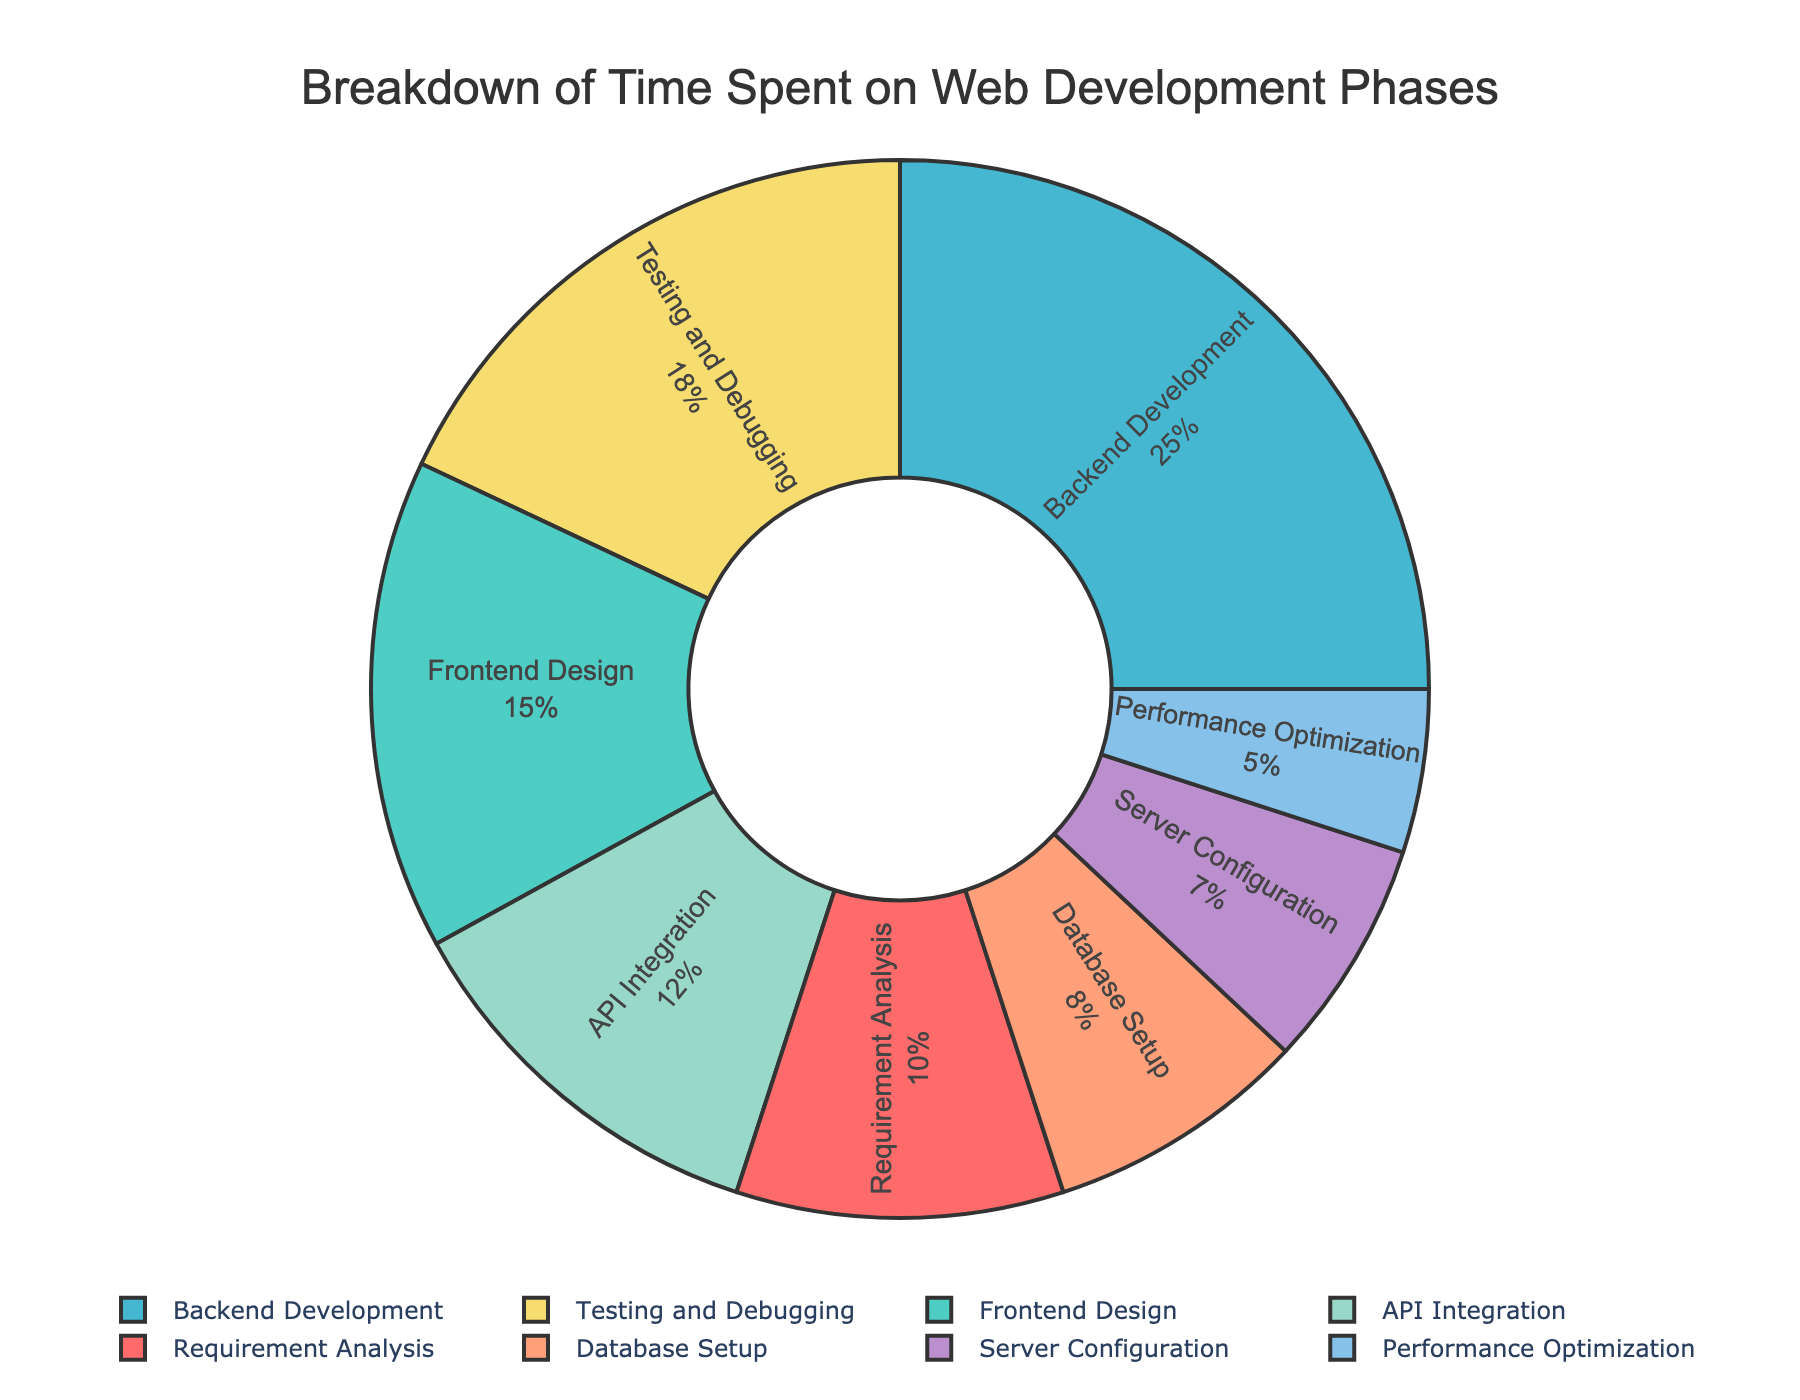Which phase takes up the highest percentage of time in the project? The pie chart shows the distribution of time spent on different phases of web development projects. Backend Development has the largest slice, indicating it takes up the highest percentage.
Answer: Backend Development How much more time is spent on Frontend Design compared to Requirement Analysis? Subtract the percentage of Requirement Analysis from Frontend Design to find the difference: 15% - 10% = 5%
Answer: 5% What is the combined percentage of time spent on API Integration and Performance Optimization? Add the percentages of API Integration and Performance Optimization together: 12% + 5% = 17%
Answer: 17% Which phase spends the least time, and what percentage does it represent? The pie chart indicates Performance Optimization has the smallest slice, representing the least time spent.
Answer: Performance Optimization and 5% Compare the time spent on Testing and Debugging with Server Configuration. Which is more, and by how much? Testing and Debugging is 18%, while Server Configuration is 7%. Subtract 7% from 18% to see Testing and Debugging spends more time: 18% - 7% = 11%
Answer: Testing and Debugging by 11% What percentage of time is spent on phases related to server and database settings (Database Setup and Server Configuration)? Add the percentages of Database Setup and Server Configuration: 8% + 7% = 15%
Answer: 15% If you combined the time spent on Requirement Analysis, API Integration, and Performance Optimization, what total percentage do you get? Add the percentages of Requirement Analysis, API Integration, and Performance Optimization: 10% + 12% + 5% = 27%
Answer: 27% Which two phases combined would make up the same percentage as Backend Development? Backend Development is 25%. Adding Frontend Design (15%) and Server Configuration (7%) gives 22%, which doesn't match. However, adding Requirement Analysis (10%) to Testing and Debugging (18%) gives 28%, which is closer but still not exact. The best match isn't clear with exact pairs available.
Answer: No exact pairs Which phase uses more time: API Integration or Database Setup? The pie chart shows API Integration at 12% and Database Setup at 8%.
Answer: API Integration Is the time spent on Frontend Design greater than the combined time spent on Server Configuration and Performance Optimization? Add the percentages of Server Configuration and Performance Optimization: 7% + 5% = 12%. Since Frontend Design is 15%, it is greater.
Answer: Yes 